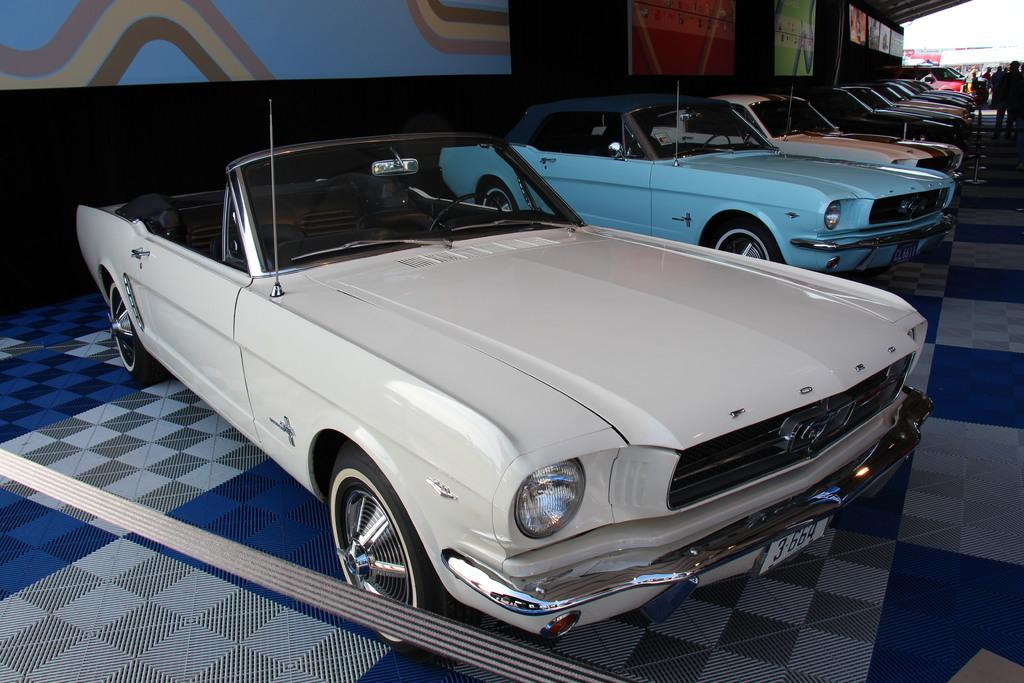What objects are on the floor in the image? There are cars on the floor in the image. What else can be seen in the image besides the cars? Boards are visible in the image. Are there any people present in the image? Yes, there are people present in the image. What can be seen in the background of the image? The sky is visible in the background of the image. What type of cub can be seen playing with a stick in the image? There is no cub or stick present in the image. How many stamps are visible on the cars in the image? There are no stamps visible on the cars in the image. 